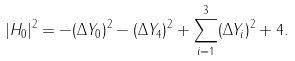Convert formula to latex. <formula><loc_0><loc_0><loc_500><loc_500>| H _ { 0 } | ^ { 2 } = - ( \Delta Y _ { 0 } ) ^ { 2 } - ( \Delta Y _ { 4 } ) ^ { 2 } + \sum _ { i = 1 } ^ { 3 } ( \Delta Y _ { i } ) ^ { 2 } + 4 .</formula> 